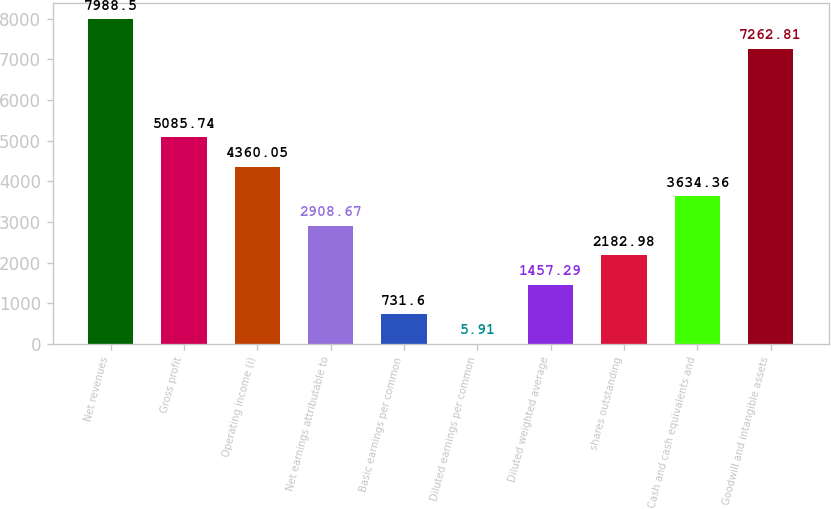Convert chart to OTSL. <chart><loc_0><loc_0><loc_500><loc_500><bar_chart><fcel>Net revenues<fcel>Gross profit<fcel>Operating income (i)<fcel>Net earnings attributable to<fcel>Basic earnings per common<fcel>Diluted earnings per common<fcel>Diluted weighted average<fcel>shares outstanding<fcel>Cash and cash equivalents and<fcel>Goodwill and intangible assets<nl><fcel>7988.5<fcel>5085.74<fcel>4360.05<fcel>2908.67<fcel>731.6<fcel>5.91<fcel>1457.29<fcel>2182.98<fcel>3634.36<fcel>7262.81<nl></chart> 